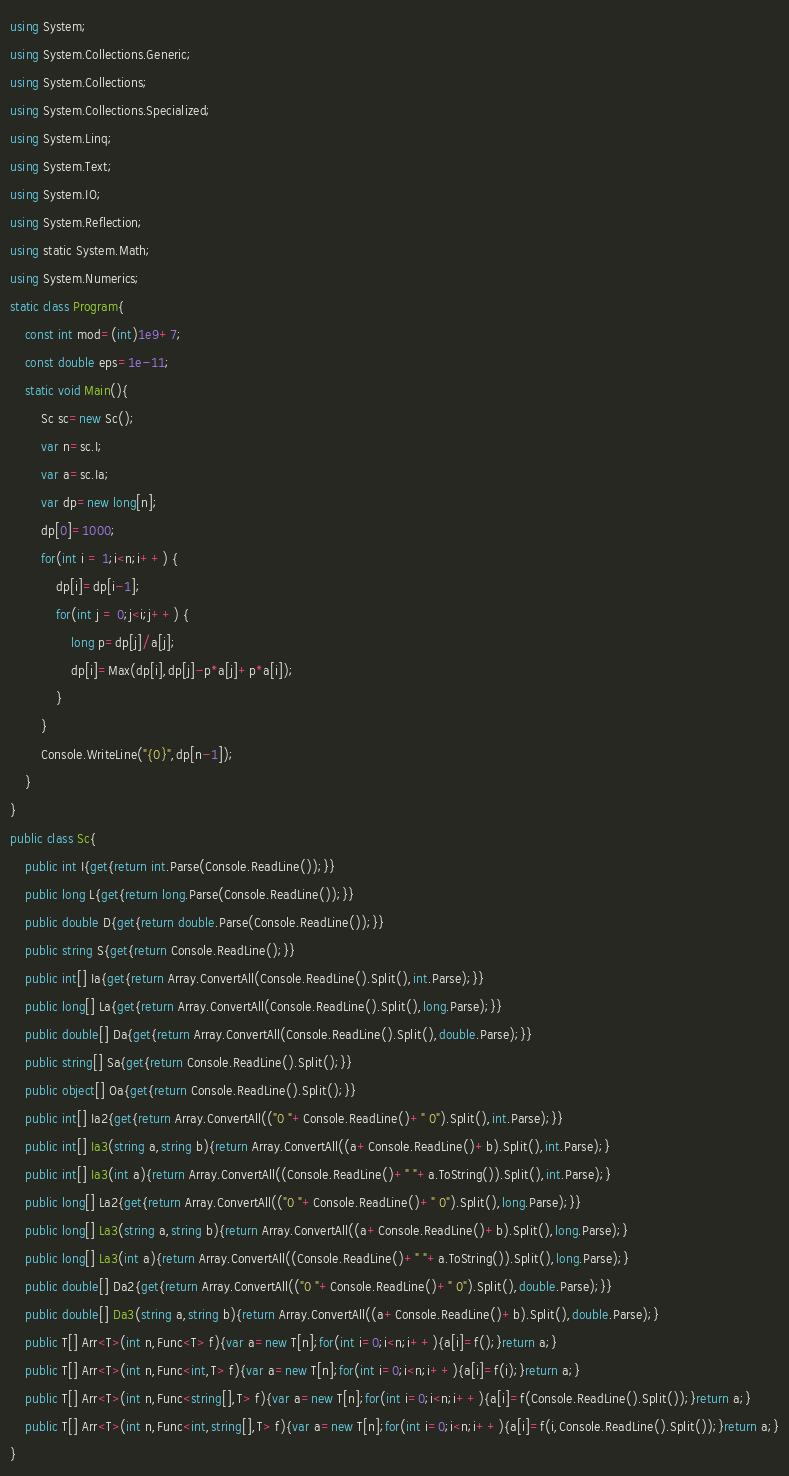Convert code to text. <code><loc_0><loc_0><loc_500><loc_500><_C#_>using System;
using System.Collections.Generic;
using System.Collections;
using System.Collections.Specialized;
using System.Linq;
using System.Text;
using System.IO;
using System.Reflection;
using static System.Math;
using System.Numerics;
static class Program{
	const int mod=(int)1e9+7;
	const double eps=1e-11;
	static void Main(){
		Sc sc=new Sc();
		var n=sc.I;
		var a=sc.Ia;
		var dp=new long[n];
		dp[0]=1000;
		for(int i = 1;i<n;i++) {
			dp[i]=dp[i-1];
			for(int j = 0;j<i;j++) {
				long p=dp[j]/a[j];
				dp[i]=Max(dp[i],dp[j]-p*a[j]+p*a[i]);
			}
		}
		Console.WriteLine("{0}",dp[n-1]);
	}
}
public class Sc{
	public int I{get{return int.Parse(Console.ReadLine());}}
	public long L{get{return long.Parse(Console.ReadLine());}}
	public double D{get{return double.Parse(Console.ReadLine());}}
	public string S{get{return Console.ReadLine();}}
	public int[] Ia{get{return Array.ConvertAll(Console.ReadLine().Split(),int.Parse);}}
	public long[] La{get{return Array.ConvertAll(Console.ReadLine().Split(),long.Parse);}}
	public double[] Da{get{return Array.ConvertAll(Console.ReadLine().Split(),double.Parse);}}
	public string[] Sa{get{return Console.ReadLine().Split();}}
	public object[] Oa{get{return Console.ReadLine().Split();}}
	public int[] Ia2{get{return Array.ConvertAll(("0 "+Console.ReadLine()+" 0").Split(),int.Parse);}}
	public int[] Ia3(string a,string b){return Array.ConvertAll((a+Console.ReadLine()+b).Split(),int.Parse);}
	public int[] Ia3(int a){return Array.ConvertAll((Console.ReadLine()+" "+a.ToString()).Split(),int.Parse);}
	public long[] La2{get{return Array.ConvertAll(("0 "+Console.ReadLine()+" 0").Split(),long.Parse);}}
	public long[] La3(string a,string b){return Array.ConvertAll((a+Console.ReadLine()+b).Split(),long.Parse);}
	public long[] La3(int a){return Array.ConvertAll((Console.ReadLine()+" "+a.ToString()).Split(),long.Parse);}
	public double[] Da2{get{return Array.ConvertAll(("0 "+Console.ReadLine()+" 0").Split(),double.Parse);}}
	public double[] Da3(string a,string b){return Array.ConvertAll((a+Console.ReadLine()+b).Split(),double.Parse);}
	public T[] Arr<T>(int n,Func<T> f){var a=new T[n];for(int i=0;i<n;i++){a[i]=f();}return a;}
	public T[] Arr<T>(int n,Func<int,T> f){var a=new T[n];for(int i=0;i<n;i++){a[i]=f(i);}return a;}
	public T[] Arr<T>(int n,Func<string[],T> f){var a=new T[n];for(int i=0;i<n;i++){a[i]=f(Console.ReadLine().Split());}return a;}
	public T[] Arr<T>(int n,Func<int,string[],T> f){var a=new T[n];for(int i=0;i<n;i++){a[i]=f(i,Console.ReadLine().Split());}return a;}
}</code> 